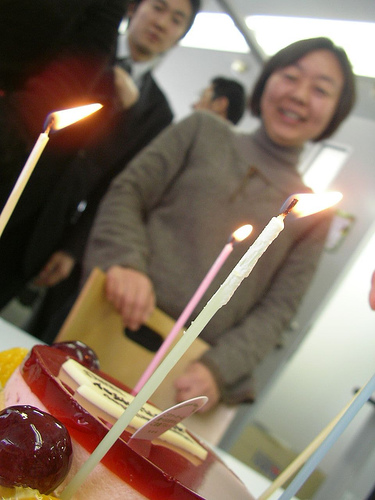Can you describe the setting of this celebratory event? The event takes place indoors with plain white walls that resemble an office or a simple room, devoid of any elaborate decorations, which emphasizes the laid-back and intimate nature of the gathering. 